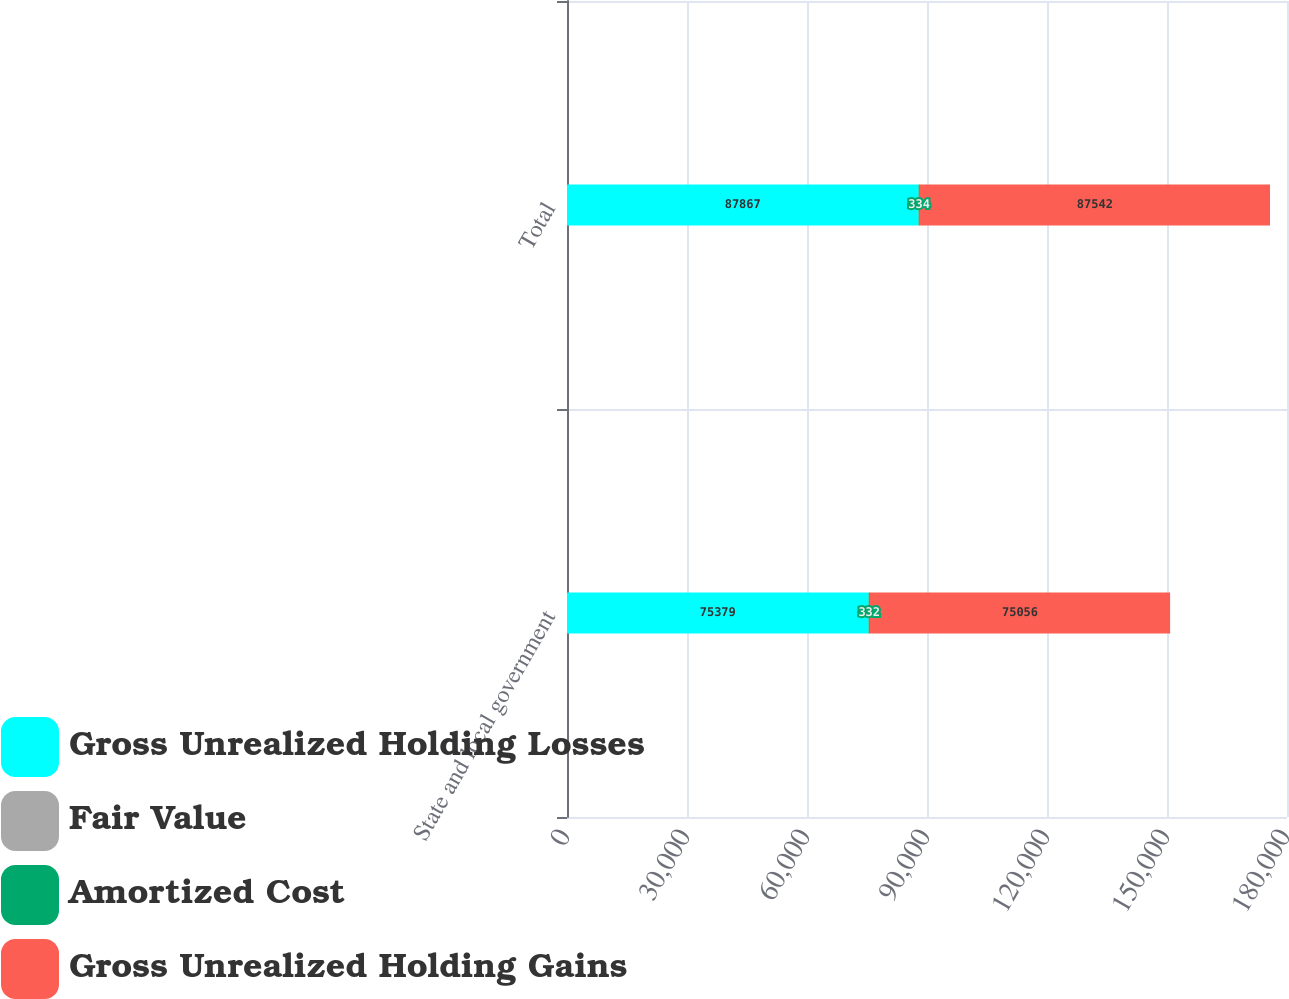<chart> <loc_0><loc_0><loc_500><loc_500><stacked_bar_chart><ecel><fcel>State and local government<fcel>Total<nl><fcel>Gross Unrealized Holding Losses<fcel>75379<fcel>87867<nl><fcel>Fair Value<fcel>9<fcel>9<nl><fcel>Amortized Cost<fcel>332<fcel>334<nl><fcel>Gross Unrealized Holding Gains<fcel>75056<fcel>87542<nl></chart> 